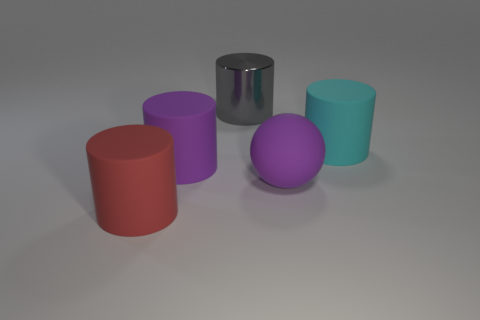What number of other things are there of the same color as the large metallic thing?
Provide a short and direct response. 0. There is a rubber object that is both in front of the big purple cylinder and to the left of the gray shiny cylinder; what is its color?
Offer a very short reply. Red. What is the size of the purple thing that is made of the same material as the ball?
Provide a succinct answer. Large. What color is the rubber thing that is to the left of the purple rubber thing to the left of the purple matte ball?
Ensure brevity in your answer.  Red. There is a big cyan matte object; is it the same shape as the large object that is behind the big cyan matte thing?
Keep it short and to the point. Yes. How many balls have the same size as the red rubber object?
Offer a very short reply. 1. What material is the other big purple object that is the same shape as the metallic object?
Provide a succinct answer. Rubber. There is a big thing on the right side of the large purple ball; is its color the same as the rubber object in front of the big matte sphere?
Ensure brevity in your answer.  No. What is the shape of the object behind the big cyan matte thing?
Provide a short and direct response. Cylinder. The large ball is what color?
Ensure brevity in your answer.  Purple. 